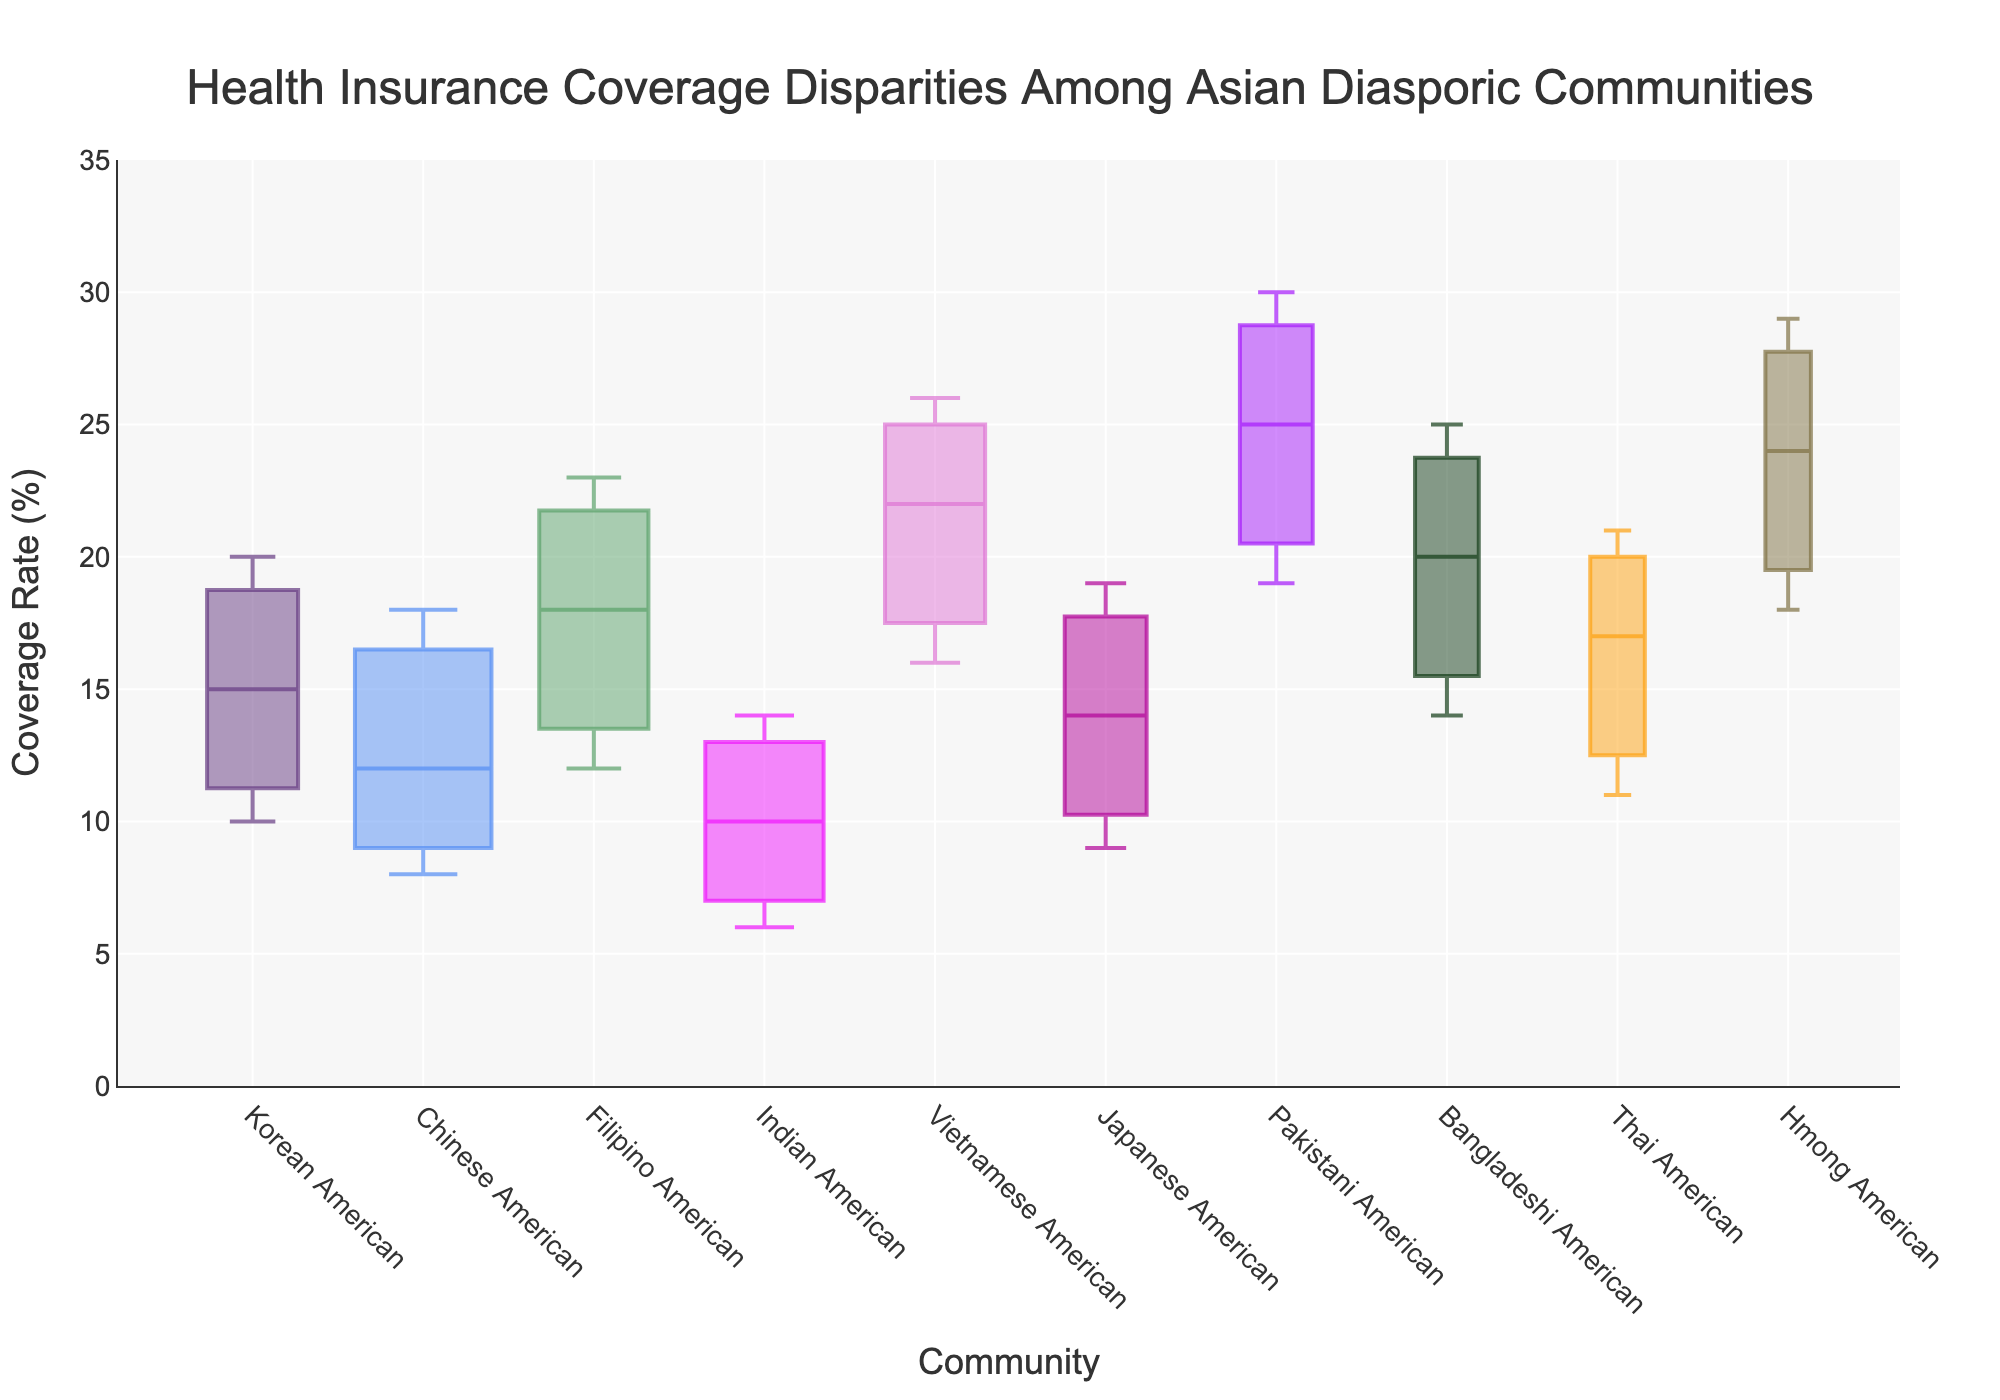Which community has the highest median health insurance coverage rate? The median value is indicated by the central mark in each box. The community with the highest central mark is the Pakistani American community, with a median value of 25.
Answer: Pakistani American What is the range (difference between the upper quartile and lower quartile) of health insurance coverage for the Vietnamese American community? The range is calculated by subtracting the lower quartile from the upper quartile. For the Vietnamese American community: 26 - 16 = 10.
Answer: 10 Which community has the smallest sample size and what is their median coverage rate? The width of the box represents the sample size, and the narrowest box corresponds to the Hmong American community. Their median coverage rate is the central mark, which is 24.
Answer: Hmong American, 24 Which two communities have the same interquartile range (IQR) and what is this value? The IQR is the difference between the upper and lower quartiles. Both Korean American (20-10) and Thai American (21-11) have an IQR of 10.
Answer: Korean American and Thai American, 10 Which communities have a lower quartile below 10%? The lower quartile (bottom of the box) below 10% are for Chinese American (8) and Indian American (6).
Answer: Chinese American and Indian American Order the communities by their sample size from largest to smallest. The widths of the boxes correspond to sample sizes. Largest to smallest: Chinese American, Indian American, Filipino American, Vietnamese American, Korean American, Japanese American, Pakistani American, Bangladeshi American, Thai American, Hmong American.
Answer: Chinese American, Indian American, Filipino American, Vietnamese American, Korean American, Japanese American, Pakistani American, Bangladeshi American, Thai American, Hmong American Which community's interquartile range (the range of the middle 50% of data) is the widest? The interquartile range (IQR) is the difference between the upper and lower quartiles. The community with the largest difference is Pakistani American (30 - 19 = 11).
Answer: Pakistani American How does the median health insurance coverage of Korean Americans compare to Japanese Americans? The central mark indicates the median. Korean Americans' median is 15 while Japanese Americans' is 14. Thus, 15 is greater than 14.
Answer: Korean Americans have a higher median coverage than Japanese Americans What is the combined median health insurance coverage rate for Indian American and Chinese American communities? To find the combined median, add the medians of Indian American and Chinese American communities, then divide by 2: (10 + 12)/2 = 11.
Answer: 11 